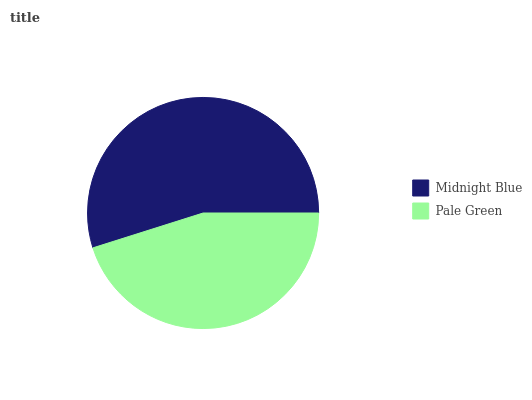Is Pale Green the minimum?
Answer yes or no. Yes. Is Midnight Blue the maximum?
Answer yes or no. Yes. Is Pale Green the maximum?
Answer yes or no. No. Is Midnight Blue greater than Pale Green?
Answer yes or no. Yes. Is Pale Green less than Midnight Blue?
Answer yes or no. Yes. Is Pale Green greater than Midnight Blue?
Answer yes or no. No. Is Midnight Blue less than Pale Green?
Answer yes or no. No. Is Midnight Blue the high median?
Answer yes or no. Yes. Is Pale Green the low median?
Answer yes or no. Yes. Is Pale Green the high median?
Answer yes or no. No. Is Midnight Blue the low median?
Answer yes or no. No. 